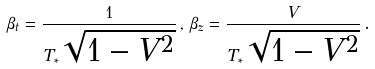Convert formula to latex. <formula><loc_0><loc_0><loc_500><loc_500>\beta _ { t } = \frac { 1 } { T _ { * } \sqrt { 1 - V ^ { 2 } } } \, , \, \beta _ { z } = \frac { V } { T _ { * } \sqrt { 1 - V ^ { 2 } } } \, .</formula> 